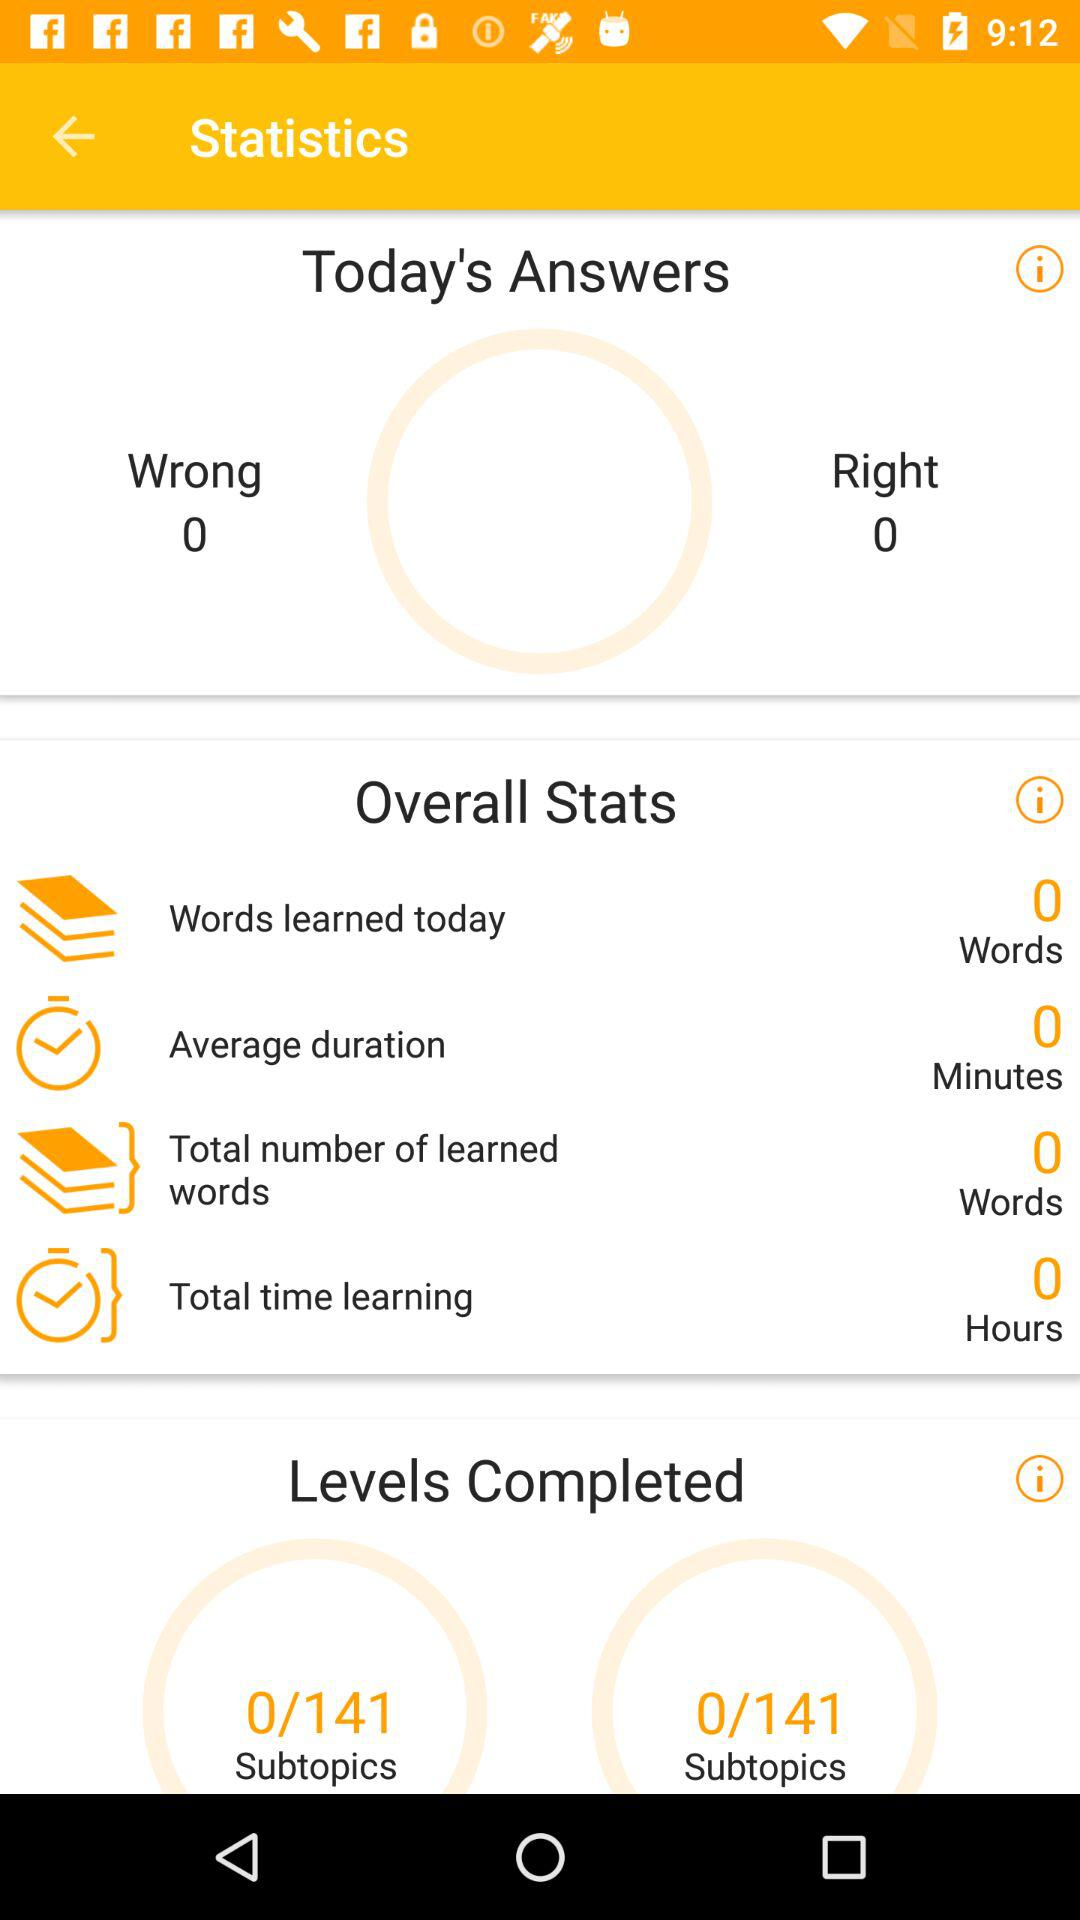What is the total number of subtopics? The total number of subtopics is 141. 